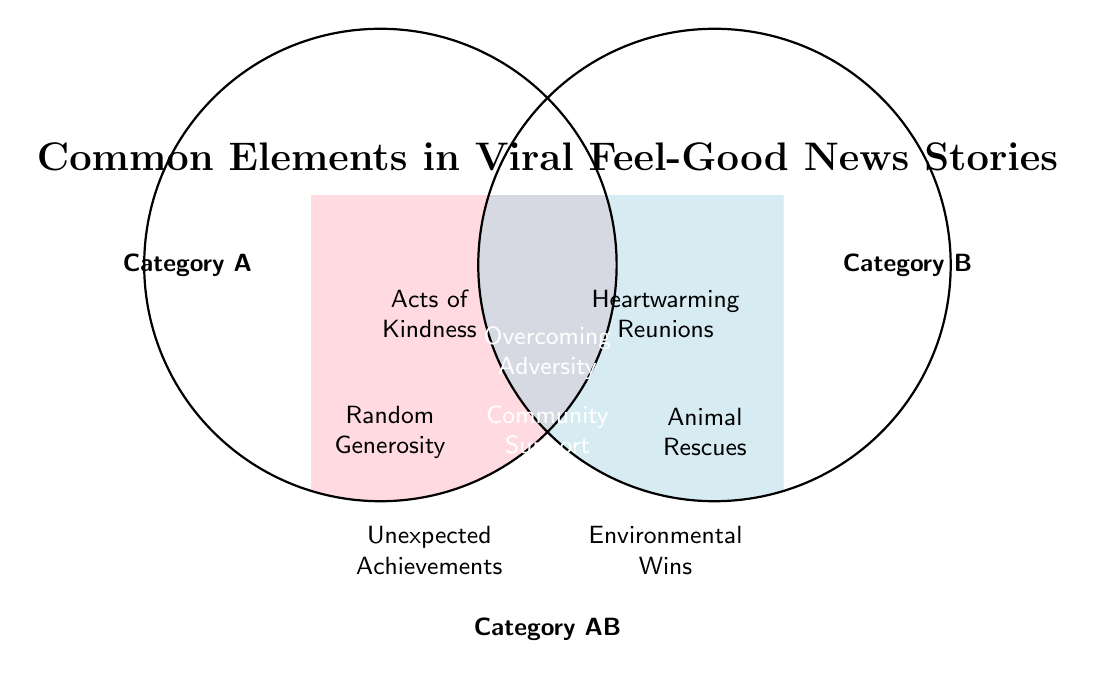What is the title of the Venn Diagram? The title is prominently displayed at the top of the diagram in a larger font size.
Answer: Common Elements in Viral Feel-Good News Stories What are the categories represented by the two main circles? The labels next to the circles indicate the categories. The left circle is labeled "Category A" and the right circle is labeled "Category B".
Answer: Category A and Category B What elements are unique to Category A? The elements in the left circle but outside the overlap area are unique to Category A. These elements are "Acts of Kindness", "Random Generosity", and "Unexpected Achievements".
Answer: Acts of Kindness, Random Generosity, Unexpected Achievements What elements are common to both Category A and Category B? The elements in the overlapping area of the two circles are common to both categories. They are "Overcoming Adversity", "Community Support", and "Inspirational Stories".
Answer: Overcoming Adversity, Community Support, Inspirational Stories Which category does "Heartwarming Reunions" belong to? "Heartwarming Reunions" is located in the right circle, outside the overlap area, which belongs to Category B.
Answer: Category B Which elements are found in Category B but not in the overlap? The elements in the right circle but outside the overlap area are unique to Category B. These elements are "Heartwarming Reunions", "Animal Rescues", and "Environmental Wins".
Answer: Heartwarming Reunions, Animal Rescues, Environmental Wins How many elements are listed in Category AB? The Venn Diagram shows three elements in the overlapping area, which represents Category AB.
Answer: Three What is the color used for representing the unique area of Category A? The color of the left circle representing Category A has a pinkish hue.
Answer: Pink How does the number of unique elements in Category A compare to the number of unique elements in Category B? There are three unique elements listed for Category A and three unique elements listed for Category B; thus, they have the same number of unique elements.
Answer: Equal 